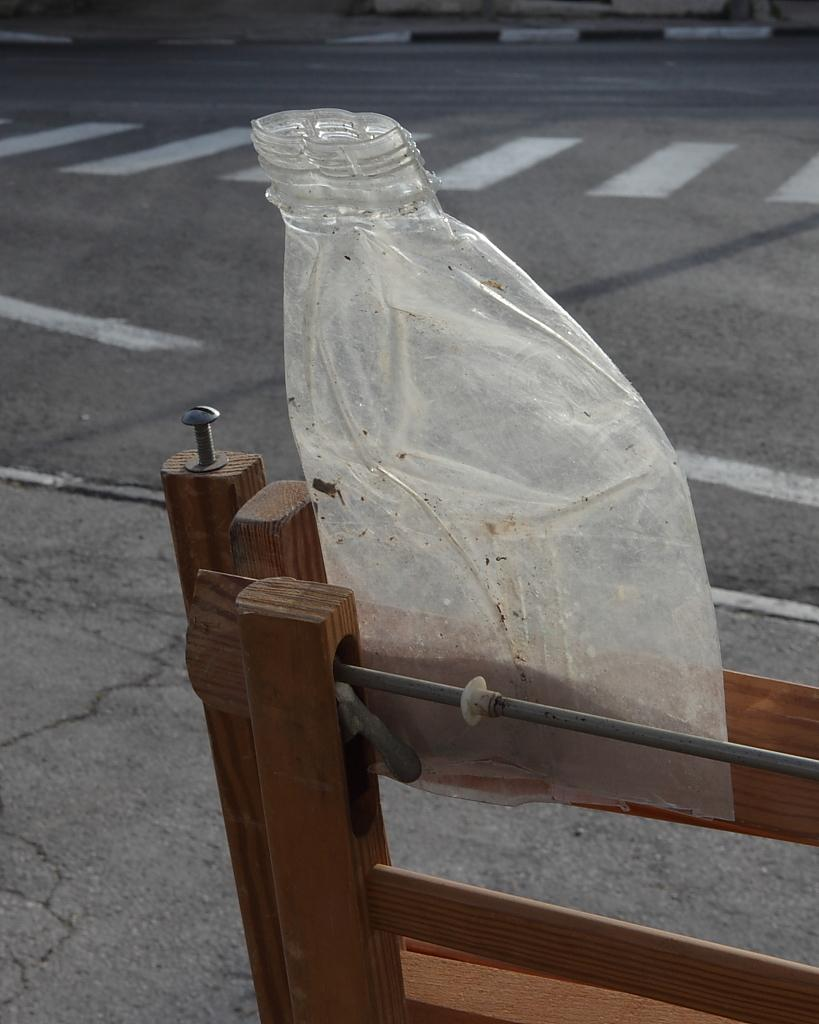What is the condition of the plastic bottle in the image? The plastic bottle is crushed in the image. On what surface is the crushed plastic bottle placed? The crushed plastic bottle is on a wooden object. What type of environment can be seen in the image? There is a road visible in the image. Can you see a snail moving along the road in the image? There is no snail visible in the image. What type of mark is left by the crushed plastic bottle on the wooden object? The crushed plastic bottle is not making any marks on the wooden object in the image. 